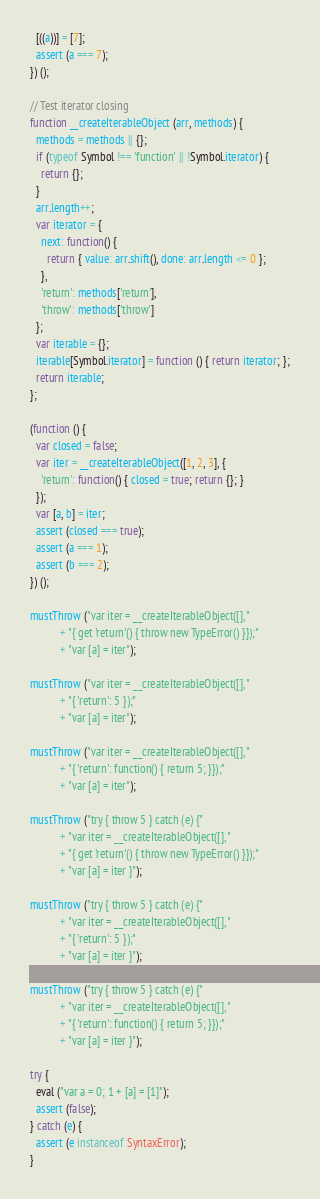<code> <loc_0><loc_0><loc_500><loc_500><_JavaScript_>  [((a))] = [7];
  assert (a === 7);
}) ();

// Test iterator closing
function __createIterableObject (arr, methods) {
  methods = methods || {};
  if (typeof Symbol !== 'function' || !Symbol.iterator) {
    return {};
  }
  arr.length++;
  var iterator = {
    next: function() {
      return { value: arr.shift(), done: arr.length <= 0 };
    },
    'return': methods['return'],
    'throw': methods['throw']
  };
  var iterable = {};
  iterable[Symbol.iterator] = function () { return iterator; };
  return iterable;
};

(function () {
  var closed = false;
  var iter = __createIterableObject([1, 2, 3], {
    'return': function() { closed = true; return {}; }
  });
  var [a, b] = iter;
  assert (closed === true);
  assert (a === 1);
  assert (b === 2);
}) ();

mustThrow ("var iter = __createIterableObject([], "
           + "{ get 'return'() { throw new TypeError() }});"
           + "var [a] = iter");

mustThrow ("var iter = __createIterableObject([], "
           + "{ 'return': 5 });"
           + "var [a] = iter");

mustThrow ("var iter = __createIterableObject([], "
           + "{ 'return': function() { return 5; }});"
           + "var [a] = iter");

mustThrow ("try { throw 5 } catch (e) {"
           + "var iter = __createIterableObject([], "
           + "{ get 'return'() { throw new TypeError() }});"
           + "var [a] = iter }");

mustThrow ("try { throw 5 } catch (e) {"
           + "var iter = __createIterableObject([], "
           + "{ 'return': 5 });"
           + "var [a] = iter }");

mustThrow ("try { throw 5 } catch (e) {"
           + "var iter = __createIterableObject([], "
           + "{ 'return': function() { return 5; }});"
           + "var [a] = iter }");

try {
  eval ("var a = 0; 1 + [a] = [1]");
  assert (false);
} catch (e) {
  assert (e instanceof SyntaxError);
}
</code> 